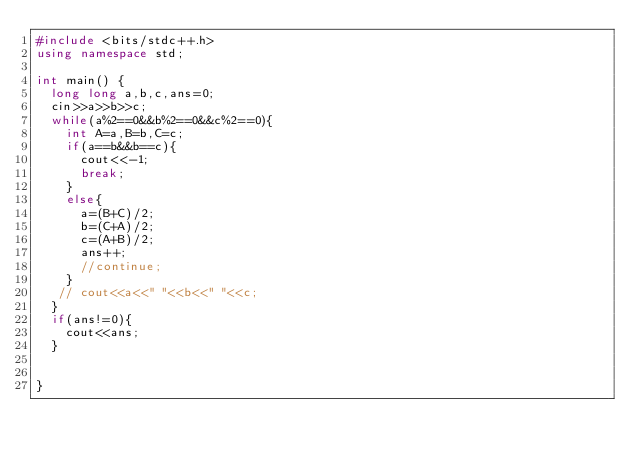Convert code to text. <code><loc_0><loc_0><loc_500><loc_500><_C++_>#include <bits/stdc++.h>
using namespace std;

int main() {
  long long a,b,c,ans=0;
  cin>>a>>b>>c;
  while(a%2==0&&b%2==0&&c%2==0){
    int A=a,B=b,C=c;
    if(a==b&&b==c){
      cout<<-1;
      break;
    }
    else{
      a=(B+C)/2;
      b=(C+A)/2;
      c=(A+B)/2;
      ans++;
      //continue;
    }
   // cout<<a<<" "<<b<<" "<<c;
  }
  if(ans!=0){
    cout<<ans;
  }
  

}</code> 